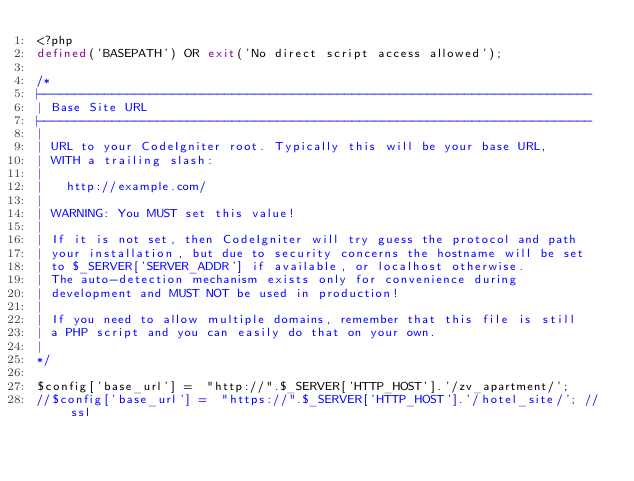<code> <loc_0><loc_0><loc_500><loc_500><_PHP_><?php
defined('BASEPATH') OR exit('No direct script access allowed');

/*
|--------------------------------------------------------------------------
| Base Site URL
|--------------------------------------------------------------------------
|
| URL to your CodeIgniter root. Typically this will be your base URL,
| WITH a trailing slash:
|
|	http://example.com/
|
| WARNING: You MUST set this value!
|
| If it is not set, then CodeIgniter will try guess the protocol and path
| your installation, but due to security concerns the hostname will be set
| to $_SERVER['SERVER_ADDR'] if available, or localhost otherwise.
| The auto-detection mechanism exists only for convenience during
| development and MUST NOT be used in production!
|
| If you need to allow multiple domains, remember that this file is still
| a PHP script and you can easily do that on your own.
|
*/

$config['base_url'] =  "http://".$_SERVER['HTTP_HOST'].'/zv_apartment/';
//$config['base_url'] =  "https://".$_SERVER['HTTP_HOST'].'/hotel_site/'; // ssl</code> 